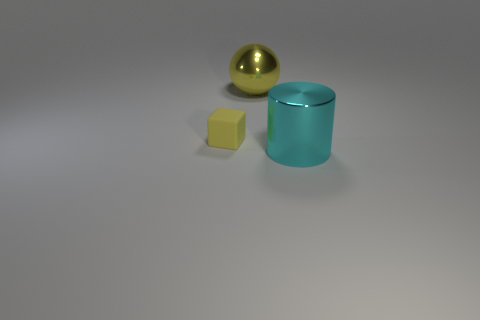Is the size of the cyan cylinder the same as the yellow ball?
Keep it short and to the point. Yes. There is a metallic thing that is on the right side of the object behind the yellow matte object; how big is it?
Make the answer very short. Large. How many yellow things are left of the big shiny sphere and right of the tiny yellow block?
Ensure brevity in your answer.  0. Is there a large object that is behind the yellow matte block that is to the left of the large metal thing left of the large cyan cylinder?
Make the answer very short. Yes. What is the shape of the other thing that is the same size as the yellow shiny thing?
Offer a very short reply. Cylinder. Is there a matte thing of the same color as the big metal ball?
Provide a short and direct response. Yes. What number of big things are either yellow matte things or cyan cubes?
Make the answer very short. 0. What color is the object that is the same material as the big yellow ball?
Keep it short and to the point. Cyan. How many yellow things are made of the same material as the large cyan cylinder?
Keep it short and to the point. 1. There is a thing to the right of the yellow shiny object; does it have the same size as the yellow object that is behind the tiny yellow object?
Your response must be concise. Yes. 